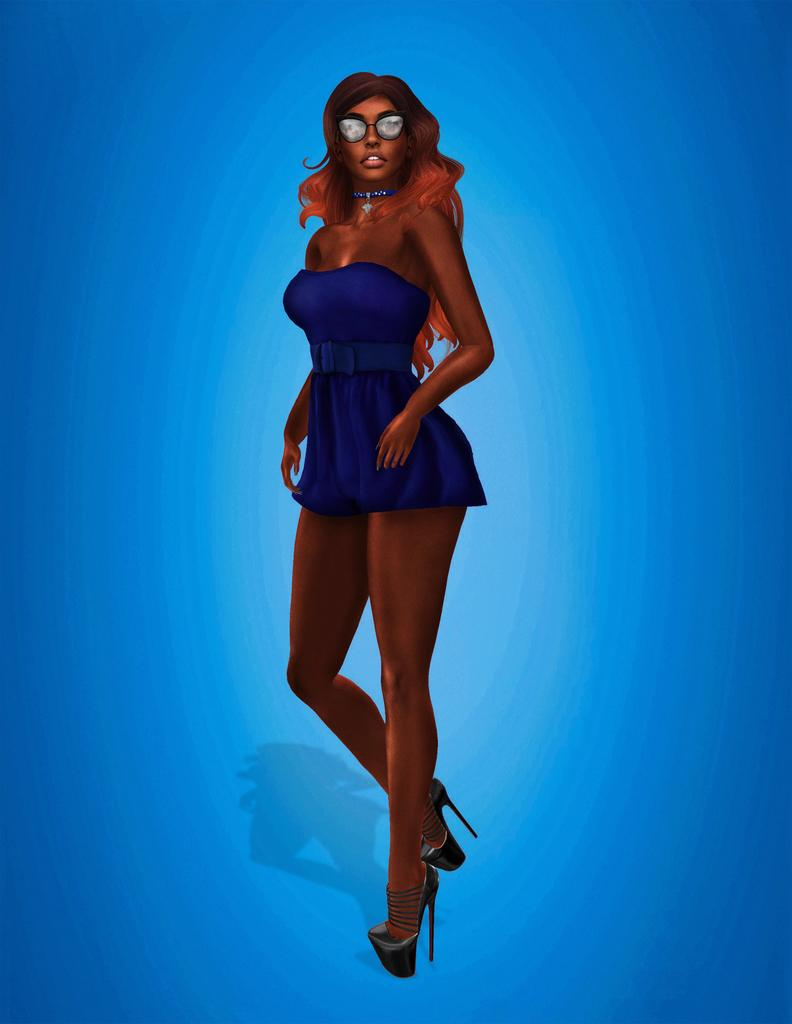What is the main subject of the painting? The painting depicts a woman. What is the woman doing in the painting? The woman is standing in the painting. What color is the dress the woman is wearing? The woman is wearing a blue dress. What is the color of the woman's hair? The woman has brown hair. What type of footwear is the woman wearing? The woman is wearing high heels. How many cent bushes are surrounding the woman in the painting? There are no cent bushes present in the painting. What type of trouble is the woman experiencing in the painting? There is no indication of trouble in the painting; the woman is simply standing and wearing a blue dress, brown hair, and high heels. 